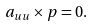Convert formula to latex. <formula><loc_0><loc_0><loc_500><loc_500>a _ { u u } \times p = 0 .</formula> 